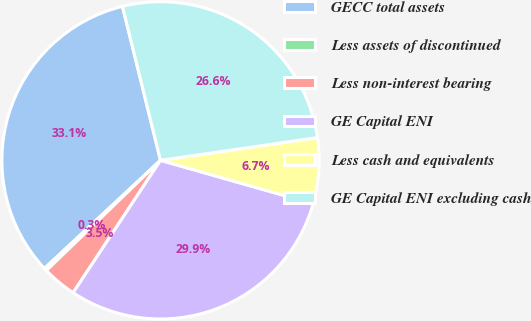Convert chart. <chart><loc_0><loc_0><loc_500><loc_500><pie_chart><fcel>GECC total assets<fcel>Less assets of discontinued<fcel>Less non-interest bearing<fcel>GE Capital ENI<fcel>Less cash and equivalents<fcel>GE Capital ENI excluding cash<nl><fcel>33.08%<fcel>0.29%<fcel>3.49%<fcel>29.88%<fcel>6.7%<fcel>26.56%<nl></chart> 